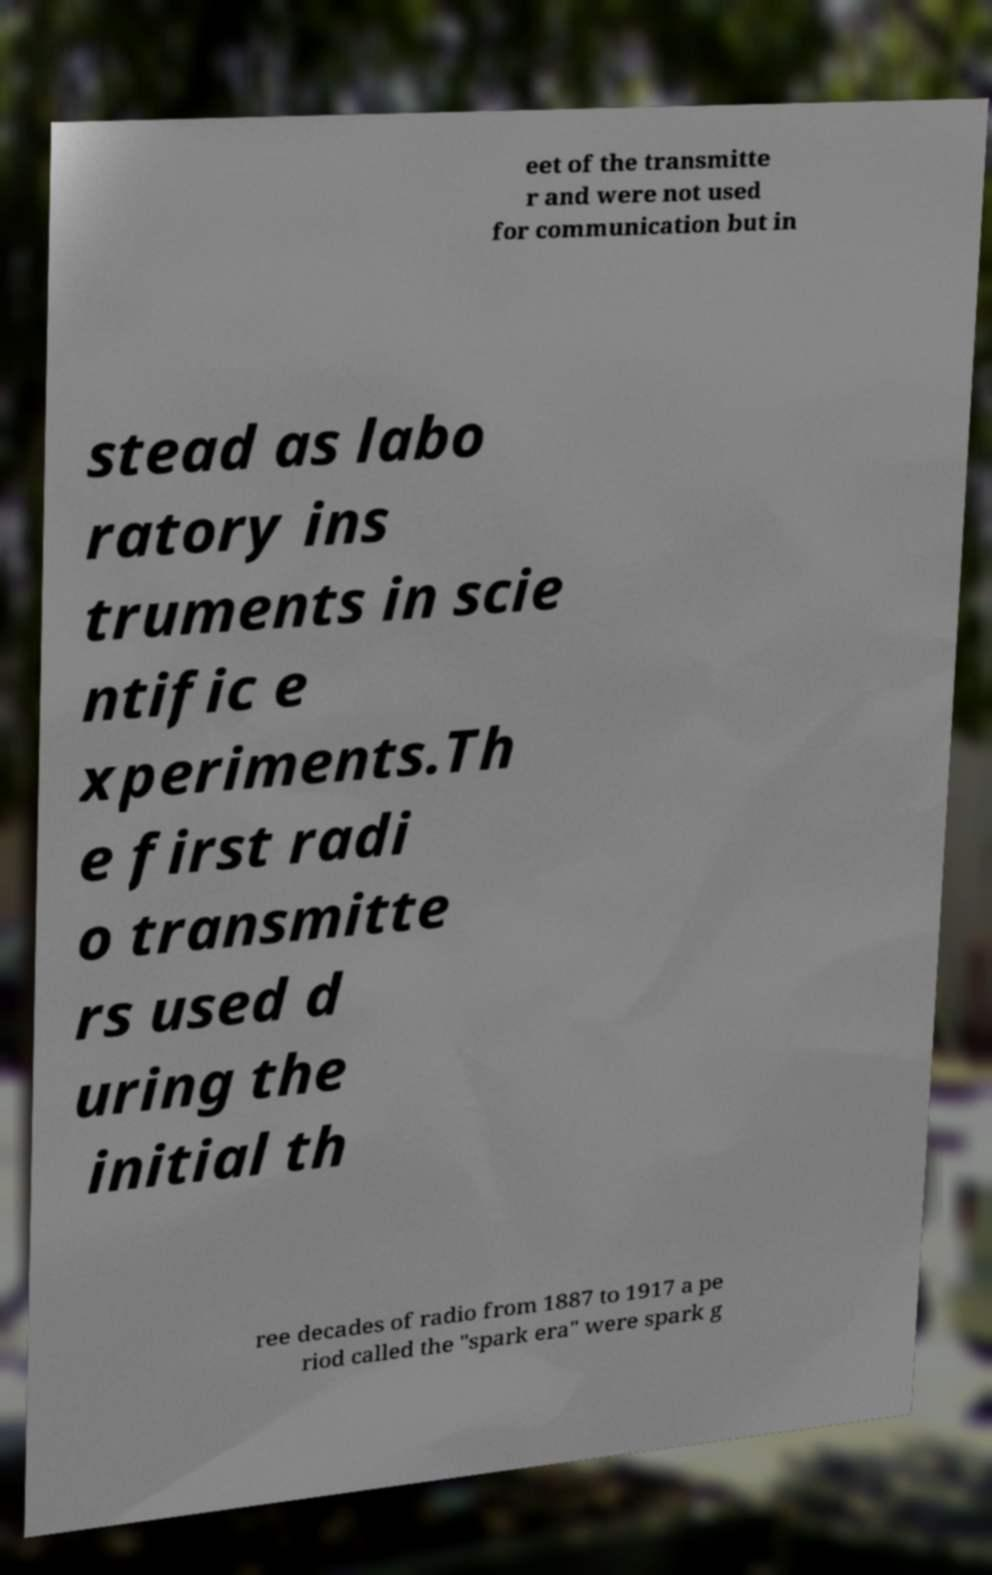I need the written content from this picture converted into text. Can you do that? eet of the transmitte r and were not used for communication but in stead as labo ratory ins truments in scie ntific e xperiments.Th e first radi o transmitte rs used d uring the initial th ree decades of radio from 1887 to 1917 a pe riod called the "spark era" were spark g 